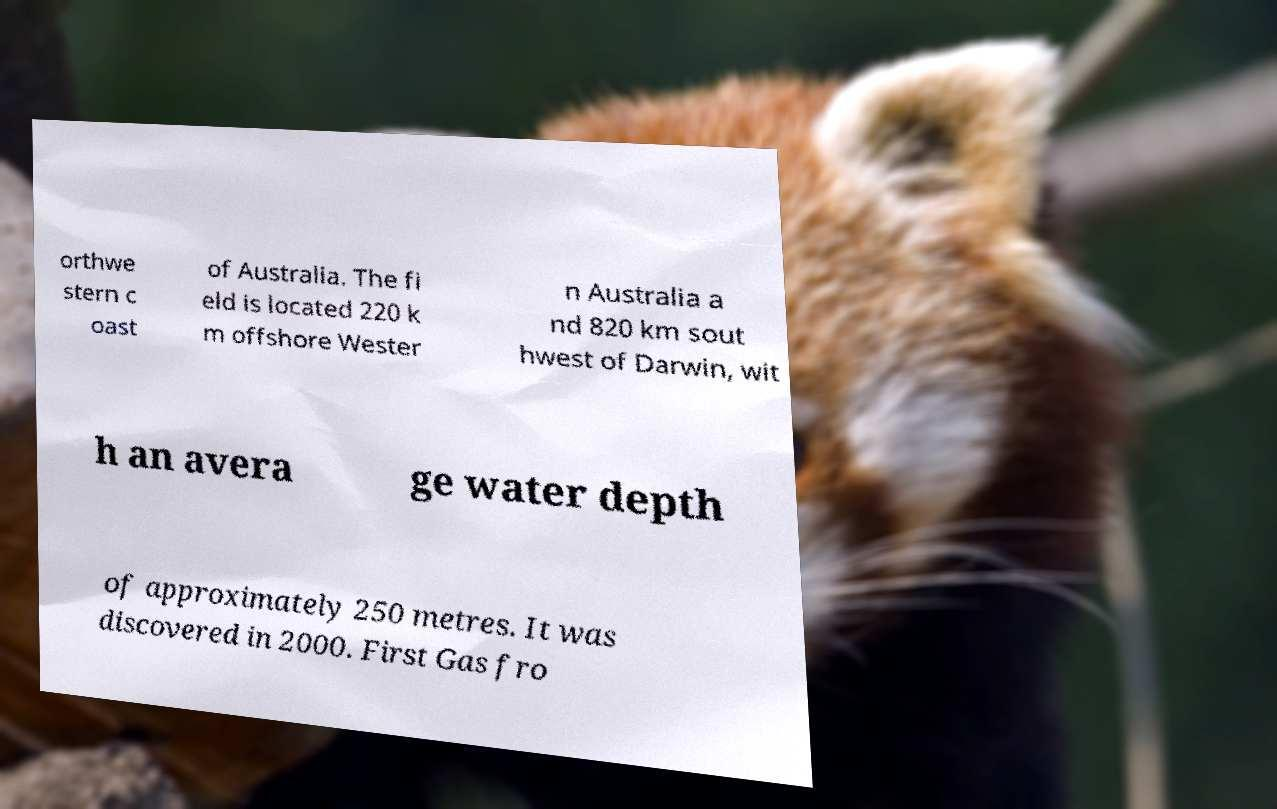I need the written content from this picture converted into text. Can you do that? orthwe stern c oast of Australia. The fi eld is located 220 k m offshore Wester n Australia a nd 820 km sout hwest of Darwin, wit h an avera ge water depth of approximately 250 metres. It was discovered in 2000. First Gas fro 